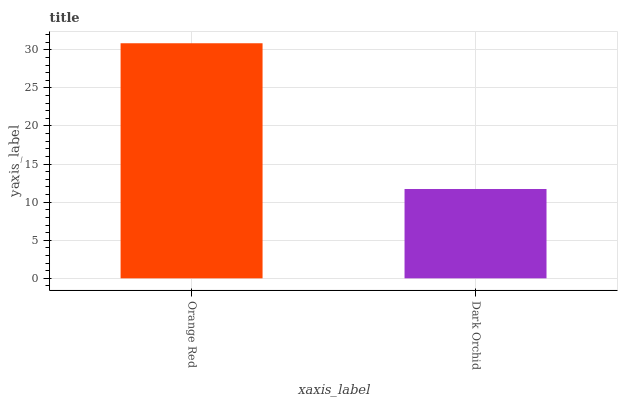Is Dark Orchid the minimum?
Answer yes or no. Yes. Is Orange Red the maximum?
Answer yes or no. Yes. Is Dark Orchid the maximum?
Answer yes or no. No. Is Orange Red greater than Dark Orchid?
Answer yes or no. Yes. Is Dark Orchid less than Orange Red?
Answer yes or no. Yes. Is Dark Orchid greater than Orange Red?
Answer yes or no. No. Is Orange Red less than Dark Orchid?
Answer yes or no. No. Is Orange Red the high median?
Answer yes or no. Yes. Is Dark Orchid the low median?
Answer yes or no. Yes. Is Dark Orchid the high median?
Answer yes or no. No. Is Orange Red the low median?
Answer yes or no. No. 